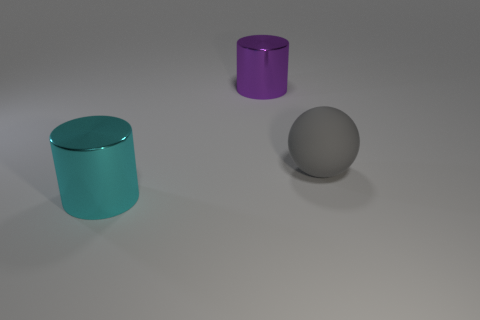Add 1 large rubber things. How many objects exist? 4 Subtract 1 spheres. How many spheres are left? 0 Subtract all purple cylinders. How many cylinders are left? 1 Subtract all cylinders. How many objects are left? 1 Subtract all yellow cylinders. Subtract all gray spheres. How many cylinders are left? 2 Subtract all gray things. Subtract all gray spheres. How many objects are left? 1 Add 2 big rubber balls. How many big rubber balls are left? 3 Add 1 large brown rubber blocks. How many large brown rubber blocks exist? 1 Subtract 0 brown cubes. How many objects are left? 3 